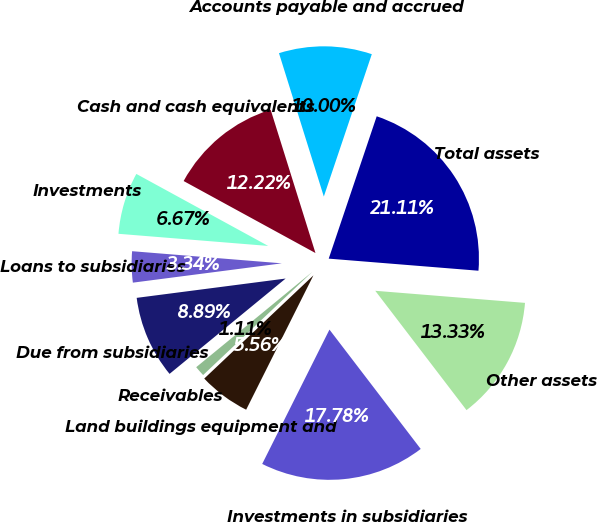Convert chart to OTSL. <chart><loc_0><loc_0><loc_500><loc_500><pie_chart><fcel>Cash and cash equivalents<fcel>Investments<fcel>Loans to subsidiaries<fcel>Due from subsidiaries<fcel>Receivables<fcel>Land buildings equipment and<fcel>Investments in subsidiaries<fcel>Other assets<fcel>Total assets<fcel>Accounts payable and accrued<nl><fcel>12.22%<fcel>6.67%<fcel>3.34%<fcel>8.89%<fcel>1.11%<fcel>5.56%<fcel>17.78%<fcel>13.33%<fcel>21.11%<fcel>10.0%<nl></chart> 